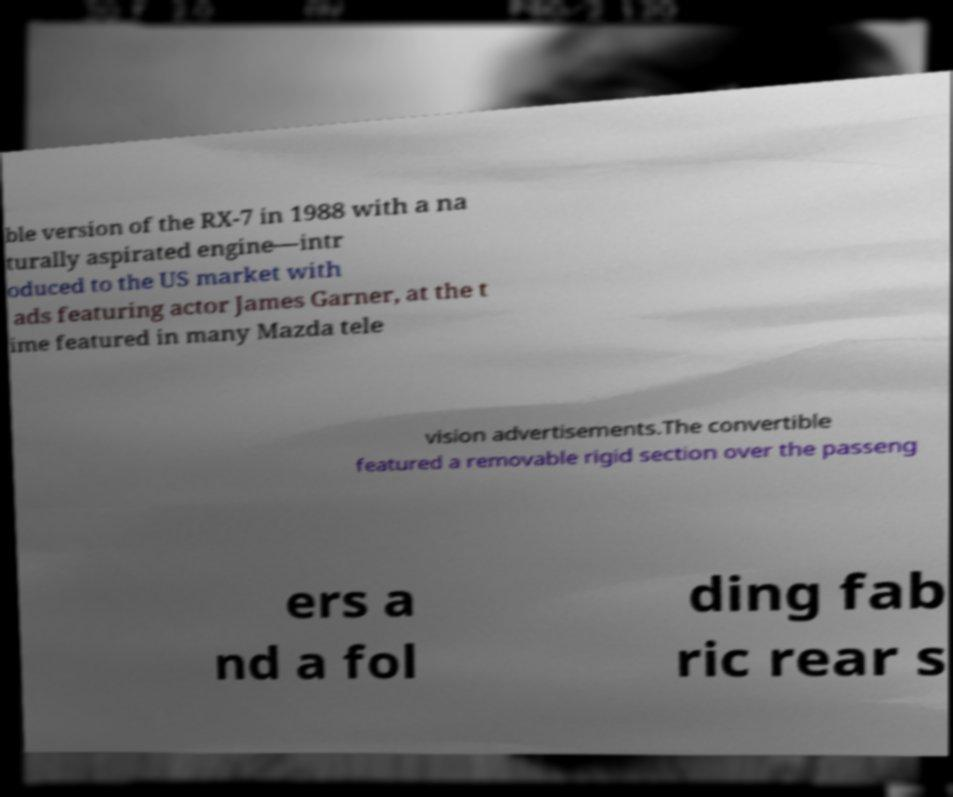For documentation purposes, I need the text within this image transcribed. Could you provide that? ble version of the RX-7 in 1988 with a na turally aspirated engine—intr oduced to the US market with ads featuring actor James Garner, at the t ime featured in many Mazda tele vision advertisements.The convertible featured a removable rigid section over the passeng ers a nd a fol ding fab ric rear s 